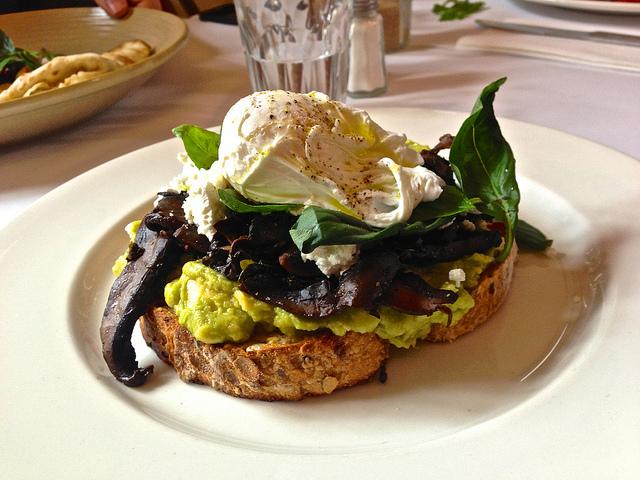What is on the other plate?
Quick response, please. Egg. What is on top of the bread?
Short answer required. Egg. Is there water in the picture?
Quick response, please. Yes. 